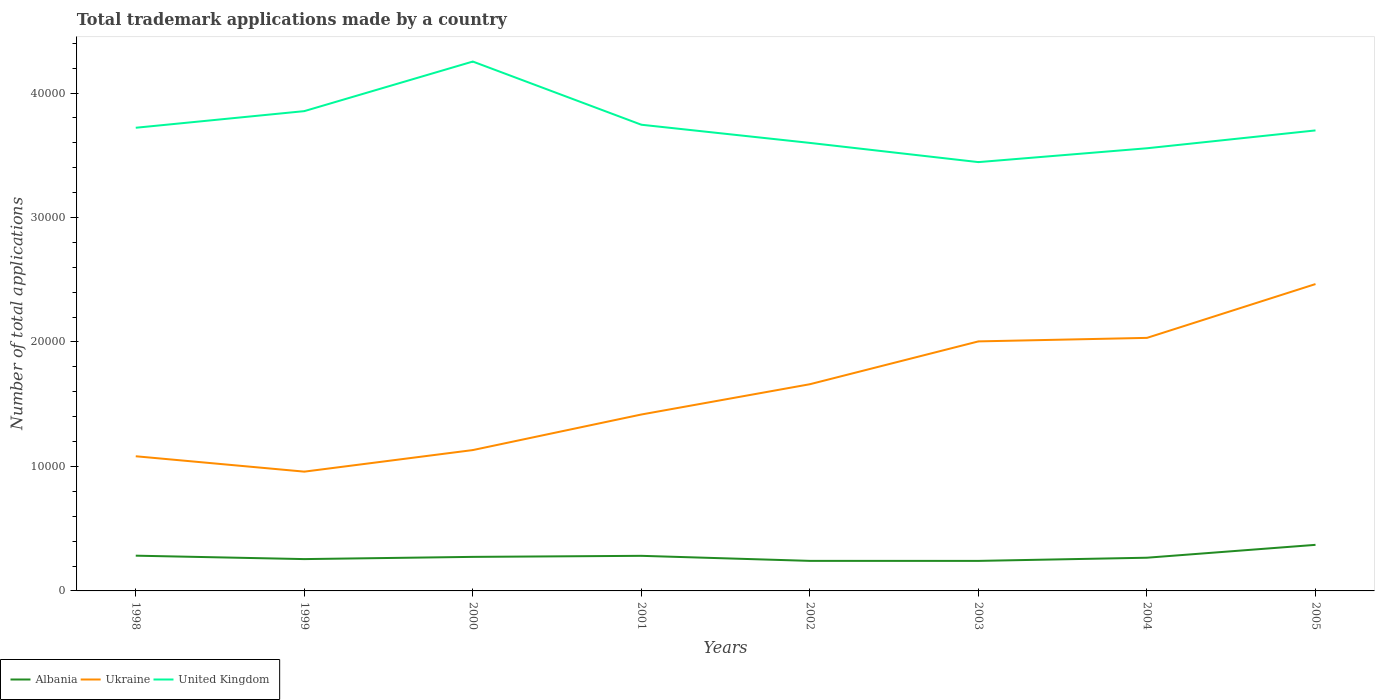Does the line corresponding to Albania intersect with the line corresponding to Ukraine?
Offer a very short reply. No. Across all years, what is the maximum number of applications made by in Ukraine?
Offer a very short reply. 9583. In which year was the number of applications made by in Albania maximum?
Your answer should be compact. 2003. What is the total number of applications made by in United Kingdom in the graph?
Your response must be concise. 1543. What is the difference between the highest and the second highest number of applications made by in Ukraine?
Provide a short and direct response. 1.51e+04. Is the number of applications made by in Albania strictly greater than the number of applications made by in United Kingdom over the years?
Provide a short and direct response. Yes. How many years are there in the graph?
Give a very brief answer. 8. Does the graph contain any zero values?
Keep it short and to the point. No. How many legend labels are there?
Give a very brief answer. 3. What is the title of the graph?
Your response must be concise. Total trademark applications made by a country. What is the label or title of the X-axis?
Offer a terse response. Years. What is the label or title of the Y-axis?
Offer a very short reply. Number of total applications. What is the Number of total applications of Albania in 1998?
Offer a very short reply. 2832. What is the Number of total applications of Ukraine in 1998?
Offer a very short reply. 1.08e+04. What is the Number of total applications of United Kingdom in 1998?
Offer a very short reply. 3.72e+04. What is the Number of total applications in Albania in 1999?
Provide a short and direct response. 2557. What is the Number of total applications in Ukraine in 1999?
Your answer should be compact. 9583. What is the Number of total applications in United Kingdom in 1999?
Keep it short and to the point. 3.85e+04. What is the Number of total applications in Albania in 2000?
Make the answer very short. 2735. What is the Number of total applications of Ukraine in 2000?
Your response must be concise. 1.13e+04. What is the Number of total applications in United Kingdom in 2000?
Provide a short and direct response. 4.25e+04. What is the Number of total applications of Albania in 2001?
Offer a terse response. 2820. What is the Number of total applications in Ukraine in 2001?
Give a very brief answer. 1.42e+04. What is the Number of total applications in United Kingdom in 2001?
Offer a very short reply. 3.75e+04. What is the Number of total applications in Albania in 2002?
Keep it short and to the point. 2414. What is the Number of total applications in Ukraine in 2002?
Keep it short and to the point. 1.66e+04. What is the Number of total applications in United Kingdom in 2002?
Ensure brevity in your answer.  3.60e+04. What is the Number of total applications in Albania in 2003?
Ensure brevity in your answer.  2413. What is the Number of total applications of Ukraine in 2003?
Your answer should be very brief. 2.00e+04. What is the Number of total applications of United Kingdom in 2003?
Your response must be concise. 3.45e+04. What is the Number of total applications of Albania in 2004?
Provide a succinct answer. 2668. What is the Number of total applications of Ukraine in 2004?
Give a very brief answer. 2.03e+04. What is the Number of total applications in United Kingdom in 2004?
Your answer should be compact. 3.56e+04. What is the Number of total applications of Albania in 2005?
Provide a succinct answer. 3702. What is the Number of total applications in Ukraine in 2005?
Keep it short and to the point. 2.47e+04. What is the Number of total applications of United Kingdom in 2005?
Keep it short and to the point. 3.70e+04. Across all years, what is the maximum Number of total applications of Albania?
Provide a short and direct response. 3702. Across all years, what is the maximum Number of total applications in Ukraine?
Give a very brief answer. 2.47e+04. Across all years, what is the maximum Number of total applications in United Kingdom?
Make the answer very short. 4.25e+04. Across all years, what is the minimum Number of total applications of Albania?
Your answer should be compact. 2413. Across all years, what is the minimum Number of total applications in Ukraine?
Your response must be concise. 9583. Across all years, what is the minimum Number of total applications of United Kingdom?
Your response must be concise. 3.45e+04. What is the total Number of total applications in Albania in the graph?
Make the answer very short. 2.21e+04. What is the total Number of total applications of Ukraine in the graph?
Ensure brevity in your answer.  1.28e+05. What is the total Number of total applications in United Kingdom in the graph?
Your answer should be compact. 2.99e+05. What is the difference between the Number of total applications in Albania in 1998 and that in 1999?
Keep it short and to the point. 275. What is the difference between the Number of total applications of Ukraine in 1998 and that in 1999?
Provide a short and direct response. 1236. What is the difference between the Number of total applications of United Kingdom in 1998 and that in 1999?
Your answer should be very brief. -1336. What is the difference between the Number of total applications of Albania in 1998 and that in 2000?
Offer a terse response. 97. What is the difference between the Number of total applications of Ukraine in 1998 and that in 2000?
Your response must be concise. -497. What is the difference between the Number of total applications in United Kingdom in 1998 and that in 2000?
Offer a very short reply. -5320. What is the difference between the Number of total applications in Ukraine in 1998 and that in 2001?
Ensure brevity in your answer.  -3355. What is the difference between the Number of total applications of United Kingdom in 1998 and that in 2001?
Make the answer very short. -243. What is the difference between the Number of total applications in Albania in 1998 and that in 2002?
Your answer should be very brief. 418. What is the difference between the Number of total applications in Ukraine in 1998 and that in 2002?
Your answer should be very brief. -5788. What is the difference between the Number of total applications in United Kingdom in 1998 and that in 2002?
Your response must be concise. 1217. What is the difference between the Number of total applications of Albania in 1998 and that in 2003?
Offer a terse response. 419. What is the difference between the Number of total applications in Ukraine in 1998 and that in 2003?
Offer a terse response. -9229. What is the difference between the Number of total applications of United Kingdom in 1998 and that in 2003?
Make the answer very short. 2760. What is the difference between the Number of total applications in Albania in 1998 and that in 2004?
Ensure brevity in your answer.  164. What is the difference between the Number of total applications of Ukraine in 1998 and that in 2004?
Make the answer very short. -9511. What is the difference between the Number of total applications of United Kingdom in 1998 and that in 2004?
Your response must be concise. 1647. What is the difference between the Number of total applications of Albania in 1998 and that in 2005?
Offer a terse response. -870. What is the difference between the Number of total applications of Ukraine in 1998 and that in 2005?
Ensure brevity in your answer.  -1.38e+04. What is the difference between the Number of total applications of United Kingdom in 1998 and that in 2005?
Provide a succinct answer. 213. What is the difference between the Number of total applications in Albania in 1999 and that in 2000?
Give a very brief answer. -178. What is the difference between the Number of total applications in Ukraine in 1999 and that in 2000?
Offer a very short reply. -1733. What is the difference between the Number of total applications in United Kingdom in 1999 and that in 2000?
Offer a very short reply. -3984. What is the difference between the Number of total applications in Albania in 1999 and that in 2001?
Offer a very short reply. -263. What is the difference between the Number of total applications in Ukraine in 1999 and that in 2001?
Provide a short and direct response. -4591. What is the difference between the Number of total applications of United Kingdom in 1999 and that in 2001?
Provide a succinct answer. 1093. What is the difference between the Number of total applications in Albania in 1999 and that in 2002?
Your answer should be very brief. 143. What is the difference between the Number of total applications in Ukraine in 1999 and that in 2002?
Offer a very short reply. -7024. What is the difference between the Number of total applications in United Kingdom in 1999 and that in 2002?
Offer a terse response. 2553. What is the difference between the Number of total applications in Albania in 1999 and that in 2003?
Keep it short and to the point. 144. What is the difference between the Number of total applications of Ukraine in 1999 and that in 2003?
Provide a succinct answer. -1.05e+04. What is the difference between the Number of total applications in United Kingdom in 1999 and that in 2003?
Provide a succinct answer. 4096. What is the difference between the Number of total applications of Albania in 1999 and that in 2004?
Make the answer very short. -111. What is the difference between the Number of total applications in Ukraine in 1999 and that in 2004?
Provide a short and direct response. -1.07e+04. What is the difference between the Number of total applications in United Kingdom in 1999 and that in 2004?
Provide a succinct answer. 2983. What is the difference between the Number of total applications of Albania in 1999 and that in 2005?
Offer a very short reply. -1145. What is the difference between the Number of total applications in Ukraine in 1999 and that in 2005?
Offer a terse response. -1.51e+04. What is the difference between the Number of total applications of United Kingdom in 1999 and that in 2005?
Provide a succinct answer. 1549. What is the difference between the Number of total applications in Albania in 2000 and that in 2001?
Give a very brief answer. -85. What is the difference between the Number of total applications in Ukraine in 2000 and that in 2001?
Give a very brief answer. -2858. What is the difference between the Number of total applications in United Kingdom in 2000 and that in 2001?
Your response must be concise. 5077. What is the difference between the Number of total applications of Albania in 2000 and that in 2002?
Your answer should be compact. 321. What is the difference between the Number of total applications of Ukraine in 2000 and that in 2002?
Provide a short and direct response. -5291. What is the difference between the Number of total applications of United Kingdom in 2000 and that in 2002?
Your answer should be very brief. 6537. What is the difference between the Number of total applications in Albania in 2000 and that in 2003?
Provide a succinct answer. 322. What is the difference between the Number of total applications in Ukraine in 2000 and that in 2003?
Make the answer very short. -8732. What is the difference between the Number of total applications of United Kingdom in 2000 and that in 2003?
Keep it short and to the point. 8080. What is the difference between the Number of total applications of Albania in 2000 and that in 2004?
Make the answer very short. 67. What is the difference between the Number of total applications in Ukraine in 2000 and that in 2004?
Provide a succinct answer. -9014. What is the difference between the Number of total applications in United Kingdom in 2000 and that in 2004?
Give a very brief answer. 6967. What is the difference between the Number of total applications of Albania in 2000 and that in 2005?
Make the answer very short. -967. What is the difference between the Number of total applications in Ukraine in 2000 and that in 2005?
Your answer should be very brief. -1.33e+04. What is the difference between the Number of total applications in United Kingdom in 2000 and that in 2005?
Provide a succinct answer. 5533. What is the difference between the Number of total applications of Albania in 2001 and that in 2002?
Keep it short and to the point. 406. What is the difference between the Number of total applications in Ukraine in 2001 and that in 2002?
Offer a terse response. -2433. What is the difference between the Number of total applications in United Kingdom in 2001 and that in 2002?
Your response must be concise. 1460. What is the difference between the Number of total applications in Albania in 2001 and that in 2003?
Provide a succinct answer. 407. What is the difference between the Number of total applications of Ukraine in 2001 and that in 2003?
Make the answer very short. -5874. What is the difference between the Number of total applications in United Kingdom in 2001 and that in 2003?
Provide a short and direct response. 3003. What is the difference between the Number of total applications in Albania in 2001 and that in 2004?
Provide a succinct answer. 152. What is the difference between the Number of total applications of Ukraine in 2001 and that in 2004?
Offer a terse response. -6156. What is the difference between the Number of total applications of United Kingdom in 2001 and that in 2004?
Your response must be concise. 1890. What is the difference between the Number of total applications of Albania in 2001 and that in 2005?
Offer a very short reply. -882. What is the difference between the Number of total applications of Ukraine in 2001 and that in 2005?
Offer a very short reply. -1.05e+04. What is the difference between the Number of total applications in United Kingdom in 2001 and that in 2005?
Your answer should be compact. 456. What is the difference between the Number of total applications of Albania in 2002 and that in 2003?
Ensure brevity in your answer.  1. What is the difference between the Number of total applications of Ukraine in 2002 and that in 2003?
Ensure brevity in your answer.  -3441. What is the difference between the Number of total applications in United Kingdom in 2002 and that in 2003?
Give a very brief answer. 1543. What is the difference between the Number of total applications of Albania in 2002 and that in 2004?
Offer a terse response. -254. What is the difference between the Number of total applications in Ukraine in 2002 and that in 2004?
Your response must be concise. -3723. What is the difference between the Number of total applications of United Kingdom in 2002 and that in 2004?
Make the answer very short. 430. What is the difference between the Number of total applications of Albania in 2002 and that in 2005?
Your answer should be compact. -1288. What is the difference between the Number of total applications in Ukraine in 2002 and that in 2005?
Your response must be concise. -8046. What is the difference between the Number of total applications in United Kingdom in 2002 and that in 2005?
Ensure brevity in your answer.  -1004. What is the difference between the Number of total applications of Albania in 2003 and that in 2004?
Provide a short and direct response. -255. What is the difference between the Number of total applications in Ukraine in 2003 and that in 2004?
Ensure brevity in your answer.  -282. What is the difference between the Number of total applications in United Kingdom in 2003 and that in 2004?
Your answer should be compact. -1113. What is the difference between the Number of total applications in Albania in 2003 and that in 2005?
Keep it short and to the point. -1289. What is the difference between the Number of total applications in Ukraine in 2003 and that in 2005?
Keep it short and to the point. -4605. What is the difference between the Number of total applications of United Kingdom in 2003 and that in 2005?
Ensure brevity in your answer.  -2547. What is the difference between the Number of total applications in Albania in 2004 and that in 2005?
Make the answer very short. -1034. What is the difference between the Number of total applications of Ukraine in 2004 and that in 2005?
Provide a succinct answer. -4323. What is the difference between the Number of total applications in United Kingdom in 2004 and that in 2005?
Give a very brief answer. -1434. What is the difference between the Number of total applications in Albania in 1998 and the Number of total applications in Ukraine in 1999?
Keep it short and to the point. -6751. What is the difference between the Number of total applications in Albania in 1998 and the Number of total applications in United Kingdom in 1999?
Your response must be concise. -3.57e+04. What is the difference between the Number of total applications in Ukraine in 1998 and the Number of total applications in United Kingdom in 1999?
Your answer should be compact. -2.77e+04. What is the difference between the Number of total applications of Albania in 1998 and the Number of total applications of Ukraine in 2000?
Ensure brevity in your answer.  -8484. What is the difference between the Number of total applications in Albania in 1998 and the Number of total applications in United Kingdom in 2000?
Your answer should be very brief. -3.97e+04. What is the difference between the Number of total applications of Ukraine in 1998 and the Number of total applications of United Kingdom in 2000?
Offer a very short reply. -3.17e+04. What is the difference between the Number of total applications of Albania in 1998 and the Number of total applications of Ukraine in 2001?
Keep it short and to the point. -1.13e+04. What is the difference between the Number of total applications in Albania in 1998 and the Number of total applications in United Kingdom in 2001?
Keep it short and to the point. -3.46e+04. What is the difference between the Number of total applications in Ukraine in 1998 and the Number of total applications in United Kingdom in 2001?
Your answer should be very brief. -2.66e+04. What is the difference between the Number of total applications in Albania in 1998 and the Number of total applications in Ukraine in 2002?
Provide a succinct answer. -1.38e+04. What is the difference between the Number of total applications of Albania in 1998 and the Number of total applications of United Kingdom in 2002?
Your answer should be very brief. -3.32e+04. What is the difference between the Number of total applications of Ukraine in 1998 and the Number of total applications of United Kingdom in 2002?
Give a very brief answer. -2.52e+04. What is the difference between the Number of total applications of Albania in 1998 and the Number of total applications of Ukraine in 2003?
Provide a short and direct response. -1.72e+04. What is the difference between the Number of total applications in Albania in 1998 and the Number of total applications in United Kingdom in 2003?
Offer a very short reply. -3.16e+04. What is the difference between the Number of total applications in Ukraine in 1998 and the Number of total applications in United Kingdom in 2003?
Offer a terse response. -2.36e+04. What is the difference between the Number of total applications of Albania in 1998 and the Number of total applications of Ukraine in 2004?
Ensure brevity in your answer.  -1.75e+04. What is the difference between the Number of total applications in Albania in 1998 and the Number of total applications in United Kingdom in 2004?
Your answer should be compact. -3.27e+04. What is the difference between the Number of total applications in Ukraine in 1998 and the Number of total applications in United Kingdom in 2004?
Make the answer very short. -2.47e+04. What is the difference between the Number of total applications of Albania in 1998 and the Number of total applications of Ukraine in 2005?
Offer a very short reply. -2.18e+04. What is the difference between the Number of total applications of Albania in 1998 and the Number of total applications of United Kingdom in 2005?
Provide a short and direct response. -3.42e+04. What is the difference between the Number of total applications in Ukraine in 1998 and the Number of total applications in United Kingdom in 2005?
Offer a terse response. -2.62e+04. What is the difference between the Number of total applications of Albania in 1999 and the Number of total applications of Ukraine in 2000?
Your answer should be compact. -8759. What is the difference between the Number of total applications of Albania in 1999 and the Number of total applications of United Kingdom in 2000?
Keep it short and to the point. -4.00e+04. What is the difference between the Number of total applications of Ukraine in 1999 and the Number of total applications of United Kingdom in 2000?
Give a very brief answer. -3.29e+04. What is the difference between the Number of total applications in Albania in 1999 and the Number of total applications in Ukraine in 2001?
Make the answer very short. -1.16e+04. What is the difference between the Number of total applications in Albania in 1999 and the Number of total applications in United Kingdom in 2001?
Your response must be concise. -3.49e+04. What is the difference between the Number of total applications in Ukraine in 1999 and the Number of total applications in United Kingdom in 2001?
Offer a terse response. -2.79e+04. What is the difference between the Number of total applications in Albania in 1999 and the Number of total applications in Ukraine in 2002?
Give a very brief answer. -1.40e+04. What is the difference between the Number of total applications of Albania in 1999 and the Number of total applications of United Kingdom in 2002?
Your answer should be compact. -3.34e+04. What is the difference between the Number of total applications in Ukraine in 1999 and the Number of total applications in United Kingdom in 2002?
Keep it short and to the point. -2.64e+04. What is the difference between the Number of total applications in Albania in 1999 and the Number of total applications in Ukraine in 2003?
Provide a succinct answer. -1.75e+04. What is the difference between the Number of total applications of Albania in 1999 and the Number of total applications of United Kingdom in 2003?
Provide a short and direct response. -3.19e+04. What is the difference between the Number of total applications in Ukraine in 1999 and the Number of total applications in United Kingdom in 2003?
Give a very brief answer. -2.49e+04. What is the difference between the Number of total applications in Albania in 1999 and the Number of total applications in Ukraine in 2004?
Make the answer very short. -1.78e+04. What is the difference between the Number of total applications in Albania in 1999 and the Number of total applications in United Kingdom in 2004?
Provide a succinct answer. -3.30e+04. What is the difference between the Number of total applications of Ukraine in 1999 and the Number of total applications of United Kingdom in 2004?
Offer a very short reply. -2.60e+04. What is the difference between the Number of total applications of Albania in 1999 and the Number of total applications of Ukraine in 2005?
Make the answer very short. -2.21e+04. What is the difference between the Number of total applications of Albania in 1999 and the Number of total applications of United Kingdom in 2005?
Ensure brevity in your answer.  -3.44e+04. What is the difference between the Number of total applications in Ukraine in 1999 and the Number of total applications in United Kingdom in 2005?
Your answer should be very brief. -2.74e+04. What is the difference between the Number of total applications of Albania in 2000 and the Number of total applications of Ukraine in 2001?
Make the answer very short. -1.14e+04. What is the difference between the Number of total applications of Albania in 2000 and the Number of total applications of United Kingdom in 2001?
Offer a terse response. -3.47e+04. What is the difference between the Number of total applications of Ukraine in 2000 and the Number of total applications of United Kingdom in 2001?
Your response must be concise. -2.61e+04. What is the difference between the Number of total applications of Albania in 2000 and the Number of total applications of Ukraine in 2002?
Provide a short and direct response. -1.39e+04. What is the difference between the Number of total applications of Albania in 2000 and the Number of total applications of United Kingdom in 2002?
Keep it short and to the point. -3.33e+04. What is the difference between the Number of total applications of Ukraine in 2000 and the Number of total applications of United Kingdom in 2002?
Your answer should be very brief. -2.47e+04. What is the difference between the Number of total applications of Albania in 2000 and the Number of total applications of Ukraine in 2003?
Offer a very short reply. -1.73e+04. What is the difference between the Number of total applications of Albania in 2000 and the Number of total applications of United Kingdom in 2003?
Offer a very short reply. -3.17e+04. What is the difference between the Number of total applications in Ukraine in 2000 and the Number of total applications in United Kingdom in 2003?
Give a very brief answer. -2.31e+04. What is the difference between the Number of total applications of Albania in 2000 and the Number of total applications of Ukraine in 2004?
Offer a terse response. -1.76e+04. What is the difference between the Number of total applications in Albania in 2000 and the Number of total applications in United Kingdom in 2004?
Keep it short and to the point. -3.28e+04. What is the difference between the Number of total applications in Ukraine in 2000 and the Number of total applications in United Kingdom in 2004?
Give a very brief answer. -2.42e+04. What is the difference between the Number of total applications of Albania in 2000 and the Number of total applications of Ukraine in 2005?
Give a very brief answer. -2.19e+04. What is the difference between the Number of total applications in Albania in 2000 and the Number of total applications in United Kingdom in 2005?
Provide a succinct answer. -3.43e+04. What is the difference between the Number of total applications in Ukraine in 2000 and the Number of total applications in United Kingdom in 2005?
Your answer should be compact. -2.57e+04. What is the difference between the Number of total applications in Albania in 2001 and the Number of total applications in Ukraine in 2002?
Provide a short and direct response. -1.38e+04. What is the difference between the Number of total applications of Albania in 2001 and the Number of total applications of United Kingdom in 2002?
Provide a succinct answer. -3.32e+04. What is the difference between the Number of total applications of Ukraine in 2001 and the Number of total applications of United Kingdom in 2002?
Your answer should be very brief. -2.18e+04. What is the difference between the Number of total applications in Albania in 2001 and the Number of total applications in Ukraine in 2003?
Offer a very short reply. -1.72e+04. What is the difference between the Number of total applications in Albania in 2001 and the Number of total applications in United Kingdom in 2003?
Your answer should be very brief. -3.16e+04. What is the difference between the Number of total applications of Ukraine in 2001 and the Number of total applications of United Kingdom in 2003?
Provide a short and direct response. -2.03e+04. What is the difference between the Number of total applications of Albania in 2001 and the Number of total applications of Ukraine in 2004?
Your answer should be compact. -1.75e+04. What is the difference between the Number of total applications of Albania in 2001 and the Number of total applications of United Kingdom in 2004?
Keep it short and to the point. -3.27e+04. What is the difference between the Number of total applications in Ukraine in 2001 and the Number of total applications in United Kingdom in 2004?
Your response must be concise. -2.14e+04. What is the difference between the Number of total applications in Albania in 2001 and the Number of total applications in Ukraine in 2005?
Your answer should be compact. -2.18e+04. What is the difference between the Number of total applications of Albania in 2001 and the Number of total applications of United Kingdom in 2005?
Offer a terse response. -3.42e+04. What is the difference between the Number of total applications in Ukraine in 2001 and the Number of total applications in United Kingdom in 2005?
Provide a short and direct response. -2.28e+04. What is the difference between the Number of total applications in Albania in 2002 and the Number of total applications in Ukraine in 2003?
Keep it short and to the point. -1.76e+04. What is the difference between the Number of total applications in Albania in 2002 and the Number of total applications in United Kingdom in 2003?
Your response must be concise. -3.20e+04. What is the difference between the Number of total applications in Ukraine in 2002 and the Number of total applications in United Kingdom in 2003?
Your response must be concise. -1.78e+04. What is the difference between the Number of total applications in Albania in 2002 and the Number of total applications in Ukraine in 2004?
Your response must be concise. -1.79e+04. What is the difference between the Number of total applications in Albania in 2002 and the Number of total applications in United Kingdom in 2004?
Offer a terse response. -3.32e+04. What is the difference between the Number of total applications of Ukraine in 2002 and the Number of total applications of United Kingdom in 2004?
Provide a short and direct response. -1.90e+04. What is the difference between the Number of total applications in Albania in 2002 and the Number of total applications in Ukraine in 2005?
Ensure brevity in your answer.  -2.22e+04. What is the difference between the Number of total applications of Albania in 2002 and the Number of total applications of United Kingdom in 2005?
Offer a very short reply. -3.46e+04. What is the difference between the Number of total applications in Ukraine in 2002 and the Number of total applications in United Kingdom in 2005?
Provide a succinct answer. -2.04e+04. What is the difference between the Number of total applications of Albania in 2003 and the Number of total applications of Ukraine in 2004?
Ensure brevity in your answer.  -1.79e+04. What is the difference between the Number of total applications in Albania in 2003 and the Number of total applications in United Kingdom in 2004?
Ensure brevity in your answer.  -3.32e+04. What is the difference between the Number of total applications in Ukraine in 2003 and the Number of total applications in United Kingdom in 2004?
Your answer should be very brief. -1.55e+04. What is the difference between the Number of total applications in Albania in 2003 and the Number of total applications in Ukraine in 2005?
Your response must be concise. -2.22e+04. What is the difference between the Number of total applications of Albania in 2003 and the Number of total applications of United Kingdom in 2005?
Provide a short and direct response. -3.46e+04. What is the difference between the Number of total applications in Ukraine in 2003 and the Number of total applications in United Kingdom in 2005?
Give a very brief answer. -1.70e+04. What is the difference between the Number of total applications of Albania in 2004 and the Number of total applications of Ukraine in 2005?
Your answer should be very brief. -2.20e+04. What is the difference between the Number of total applications of Albania in 2004 and the Number of total applications of United Kingdom in 2005?
Provide a short and direct response. -3.43e+04. What is the difference between the Number of total applications of Ukraine in 2004 and the Number of total applications of United Kingdom in 2005?
Provide a short and direct response. -1.67e+04. What is the average Number of total applications in Albania per year?
Ensure brevity in your answer.  2767.62. What is the average Number of total applications of Ukraine per year?
Make the answer very short. 1.59e+04. What is the average Number of total applications in United Kingdom per year?
Your answer should be very brief. 3.73e+04. In the year 1998, what is the difference between the Number of total applications in Albania and Number of total applications in Ukraine?
Offer a very short reply. -7987. In the year 1998, what is the difference between the Number of total applications of Albania and Number of total applications of United Kingdom?
Offer a terse response. -3.44e+04. In the year 1998, what is the difference between the Number of total applications of Ukraine and Number of total applications of United Kingdom?
Offer a very short reply. -2.64e+04. In the year 1999, what is the difference between the Number of total applications of Albania and Number of total applications of Ukraine?
Make the answer very short. -7026. In the year 1999, what is the difference between the Number of total applications in Albania and Number of total applications in United Kingdom?
Your answer should be very brief. -3.60e+04. In the year 1999, what is the difference between the Number of total applications in Ukraine and Number of total applications in United Kingdom?
Provide a succinct answer. -2.90e+04. In the year 2000, what is the difference between the Number of total applications of Albania and Number of total applications of Ukraine?
Provide a short and direct response. -8581. In the year 2000, what is the difference between the Number of total applications in Albania and Number of total applications in United Kingdom?
Give a very brief answer. -3.98e+04. In the year 2000, what is the difference between the Number of total applications of Ukraine and Number of total applications of United Kingdom?
Your response must be concise. -3.12e+04. In the year 2001, what is the difference between the Number of total applications in Albania and Number of total applications in Ukraine?
Make the answer very short. -1.14e+04. In the year 2001, what is the difference between the Number of total applications of Albania and Number of total applications of United Kingdom?
Ensure brevity in your answer.  -3.46e+04. In the year 2001, what is the difference between the Number of total applications in Ukraine and Number of total applications in United Kingdom?
Provide a succinct answer. -2.33e+04. In the year 2002, what is the difference between the Number of total applications of Albania and Number of total applications of Ukraine?
Offer a terse response. -1.42e+04. In the year 2002, what is the difference between the Number of total applications of Albania and Number of total applications of United Kingdom?
Your answer should be very brief. -3.36e+04. In the year 2002, what is the difference between the Number of total applications of Ukraine and Number of total applications of United Kingdom?
Keep it short and to the point. -1.94e+04. In the year 2003, what is the difference between the Number of total applications of Albania and Number of total applications of Ukraine?
Your answer should be very brief. -1.76e+04. In the year 2003, what is the difference between the Number of total applications of Albania and Number of total applications of United Kingdom?
Provide a succinct answer. -3.20e+04. In the year 2003, what is the difference between the Number of total applications of Ukraine and Number of total applications of United Kingdom?
Give a very brief answer. -1.44e+04. In the year 2004, what is the difference between the Number of total applications of Albania and Number of total applications of Ukraine?
Keep it short and to the point. -1.77e+04. In the year 2004, what is the difference between the Number of total applications of Albania and Number of total applications of United Kingdom?
Give a very brief answer. -3.29e+04. In the year 2004, what is the difference between the Number of total applications of Ukraine and Number of total applications of United Kingdom?
Offer a terse response. -1.52e+04. In the year 2005, what is the difference between the Number of total applications in Albania and Number of total applications in Ukraine?
Your answer should be very brief. -2.10e+04. In the year 2005, what is the difference between the Number of total applications of Albania and Number of total applications of United Kingdom?
Ensure brevity in your answer.  -3.33e+04. In the year 2005, what is the difference between the Number of total applications of Ukraine and Number of total applications of United Kingdom?
Provide a short and direct response. -1.23e+04. What is the ratio of the Number of total applications in Albania in 1998 to that in 1999?
Your answer should be compact. 1.11. What is the ratio of the Number of total applications of Ukraine in 1998 to that in 1999?
Offer a terse response. 1.13. What is the ratio of the Number of total applications in United Kingdom in 1998 to that in 1999?
Ensure brevity in your answer.  0.97. What is the ratio of the Number of total applications in Albania in 1998 to that in 2000?
Provide a succinct answer. 1.04. What is the ratio of the Number of total applications in Ukraine in 1998 to that in 2000?
Your answer should be compact. 0.96. What is the ratio of the Number of total applications of United Kingdom in 1998 to that in 2000?
Offer a very short reply. 0.87. What is the ratio of the Number of total applications in Albania in 1998 to that in 2001?
Your answer should be very brief. 1. What is the ratio of the Number of total applications in Ukraine in 1998 to that in 2001?
Make the answer very short. 0.76. What is the ratio of the Number of total applications in United Kingdom in 1998 to that in 2001?
Provide a short and direct response. 0.99. What is the ratio of the Number of total applications of Albania in 1998 to that in 2002?
Keep it short and to the point. 1.17. What is the ratio of the Number of total applications in Ukraine in 1998 to that in 2002?
Provide a succinct answer. 0.65. What is the ratio of the Number of total applications of United Kingdom in 1998 to that in 2002?
Your answer should be very brief. 1.03. What is the ratio of the Number of total applications of Albania in 1998 to that in 2003?
Make the answer very short. 1.17. What is the ratio of the Number of total applications of Ukraine in 1998 to that in 2003?
Provide a succinct answer. 0.54. What is the ratio of the Number of total applications in United Kingdom in 1998 to that in 2003?
Make the answer very short. 1.08. What is the ratio of the Number of total applications of Albania in 1998 to that in 2004?
Provide a succinct answer. 1.06. What is the ratio of the Number of total applications of Ukraine in 1998 to that in 2004?
Your response must be concise. 0.53. What is the ratio of the Number of total applications of United Kingdom in 1998 to that in 2004?
Ensure brevity in your answer.  1.05. What is the ratio of the Number of total applications in Albania in 1998 to that in 2005?
Make the answer very short. 0.77. What is the ratio of the Number of total applications of Ukraine in 1998 to that in 2005?
Your response must be concise. 0.44. What is the ratio of the Number of total applications in Albania in 1999 to that in 2000?
Keep it short and to the point. 0.93. What is the ratio of the Number of total applications in Ukraine in 1999 to that in 2000?
Offer a very short reply. 0.85. What is the ratio of the Number of total applications in United Kingdom in 1999 to that in 2000?
Offer a terse response. 0.91. What is the ratio of the Number of total applications in Albania in 1999 to that in 2001?
Your answer should be compact. 0.91. What is the ratio of the Number of total applications in Ukraine in 1999 to that in 2001?
Offer a very short reply. 0.68. What is the ratio of the Number of total applications in United Kingdom in 1999 to that in 2001?
Keep it short and to the point. 1.03. What is the ratio of the Number of total applications of Albania in 1999 to that in 2002?
Provide a short and direct response. 1.06. What is the ratio of the Number of total applications of Ukraine in 1999 to that in 2002?
Your answer should be compact. 0.58. What is the ratio of the Number of total applications of United Kingdom in 1999 to that in 2002?
Make the answer very short. 1.07. What is the ratio of the Number of total applications in Albania in 1999 to that in 2003?
Offer a terse response. 1.06. What is the ratio of the Number of total applications in Ukraine in 1999 to that in 2003?
Give a very brief answer. 0.48. What is the ratio of the Number of total applications of United Kingdom in 1999 to that in 2003?
Give a very brief answer. 1.12. What is the ratio of the Number of total applications of Albania in 1999 to that in 2004?
Provide a short and direct response. 0.96. What is the ratio of the Number of total applications in Ukraine in 1999 to that in 2004?
Your answer should be very brief. 0.47. What is the ratio of the Number of total applications of United Kingdom in 1999 to that in 2004?
Your answer should be very brief. 1.08. What is the ratio of the Number of total applications of Albania in 1999 to that in 2005?
Your answer should be very brief. 0.69. What is the ratio of the Number of total applications in Ukraine in 1999 to that in 2005?
Ensure brevity in your answer.  0.39. What is the ratio of the Number of total applications of United Kingdom in 1999 to that in 2005?
Make the answer very short. 1.04. What is the ratio of the Number of total applications in Albania in 2000 to that in 2001?
Provide a succinct answer. 0.97. What is the ratio of the Number of total applications of Ukraine in 2000 to that in 2001?
Offer a very short reply. 0.8. What is the ratio of the Number of total applications of United Kingdom in 2000 to that in 2001?
Provide a short and direct response. 1.14. What is the ratio of the Number of total applications in Albania in 2000 to that in 2002?
Your answer should be compact. 1.13. What is the ratio of the Number of total applications in Ukraine in 2000 to that in 2002?
Provide a succinct answer. 0.68. What is the ratio of the Number of total applications in United Kingdom in 2000 to that in 2002?
Keep it short and to the point. 1.18. What is the ratio of the Number of total applications of Albania in 2000 to that in 2003?
Offer a very short reply. 1.13. What is the ratio of the Number of total applications in Ukraine in 2000 to that in 2003?
Keep it short and to the point. 0.56. What is the ratio of the Number of total applications of United Kingdom in 2000 to that in 2003?
Offer a terse response. 1.23. What is the ratio of the Number of total applications in Albania in 2000 to that in 2004?
Your answer should be very brief. 1.03. What is the ratio of the Number of total applications of Ukraine in 2000 to that in 2004?
Ensure brevity in your answer.  0.56. What is the ratio of the Number of total applications in United Kingdom in 2000 to that in 2004?
Your response must be concise. 1.2. What is the ratio of the Number of total applications of Albania in 2000 to that in 2005?
Give a very brief answer. 0.74. What is the ratio of the Number of total applications of Ukraine in 2000 to that in 2005?
Make the answer very short. 0.46. What is the ratio of the Number of total applications in United Kingdom in 2000 to that in 2005?
Give a very brief answer. 1.15. What is the ratio of the Number of total applications of Albania in 2001 to that in 2002?
Provide a succinct answer. 1.17. What is the ratio of the Number of total applications of Ukraine in 2001 to that in 2002?
Your response must be concise. 0.85. What is the ratio of the Number of total applications of United Kingdom in 2001 to that in 2002?
Ensure brevity in your answer.  1.04. What is the ratio of the Number of total applications in Albania in 2001 to that in 2003?
Offer a very short reply. 1.17. What is the ratio of the Number of total applications in Ukraine in 2001 to that in 2003?
Offer a very short reply. 0.71. What is the ratio of the Number of total applications in United Kingdom in 2001 to that in 2003?
Offer a very short reply. 1.09. What is the ratio of the Number of total applications in Albania in 2001 to that in 2004?
Give a very brief answer. 1.06. What is the ratio of the Number of total applications in Ukraine in 2001 to that in 2004?
Keep it short and to the point. 0.7. What is the ratio of the Number of total applications of United Kingdom in 2001 to that in 2004?
Give a very brief answer. 1.05. What is the ratio of the Number of total applications of Albania in 2001 to that in 2005?
Give a very brief answer. 0.76. What is the ratio of the Number of total applications of Ukraine in 2001 to that in 2005?
Keep it short and to the point. 0.57. What is the ratio of the Number of total applications of United Kingdom in 2001 to that in 2005?
Your response must be concise. 1.01. What is the ratio of the Number of total applications of Ukraine in 2002 to that in 2003?
Keep it short and to the point. 0.83. What is the ratio of the Number of total applications of United Kingdom in 2002 to that in 2003?
Keep it short and to the point. 1.04. What is the ratio of the Number of total applications of Albania in 2002 to that in 2004?
Keep it short and to the point. 0.9. What is the ratio of the Number of total applications of Ukraine in 2002 to that in 2004?
Provide a succinct answer. 0.82. What is the ratio of the Number of total applications of United Kingdom in 2002 to that in 2004?
Give a very brief answer. 1.01. What is the ratio of the Number of total applications of Albania in 2002 to that in 2005?
Provide a succinct answer. 0.65. What is the ratio of the Number of total applications in Ukraine in 2002 to that in 2005?
Offer a terse response. 0.67. What is the ratio of the Number of total applications of United Kingdom in 2002 to that in 2005?
Give a very brief answer. 0.97. What is the ratio of the Number of total applications of Albania in 2003 to that in 2004?
Make the answer very short. 0.9. What is the ratio of the Number of total applications in Ukraine in 2003 to that in 2004?
Make the answer very short. 0.99. What is the ratio of the Number of total applications of United Kingdom in 2003 to that in 2004?
Give a very brief answer. 0.97. What is the ratio of the Number of total applications of Albania in 2003 to that in 2005?
Offer a very short reply. 0.65. What is the ratio of the Number of total applications of Ukraine in 2003 to that in 2005?
Keep it short and to the point. 0.81. What is the ratio of the Number of total applications in United Kingdom in 2003 to that in 2005?
Make the answer very short. 0.93. What is the ratio of the Number of total applications in Albania in 2004 to that in 2005?
Provide a succinct answer. 0.72. What is the ratio of the Number of total applications of Ukraine in 2004 to that in 2005?
Your response must be concise. 0.82. What is the ratio of the Number of total applications in United Kingdom in 2004 to that in 2005?
Keep it short and to the point. 0.96. What is the difference between the highest and the second highest Number of total applications in Albania?
Offer a terse response. 870. What is the difference between the highest and the second highest Number of total applications of Ukraine?
Your answer should be compact. 4323. What is the difference between the highest and the second highest Number of total applications in United Kingdom?
Provide a short and direct response. 3984. What is the difference between the highest and the lowest Number of total applications in Albania?
Ensure brevity in your answer.  1289. What is the difference between the highest and the lowest Number of total applications in Ukraine?
Ensure brevity in your answer.  1.51e+04. What is the difference between the highest and the lowest Number of total applications in United Kingdom?
Your answer should be very brief. 8080. 